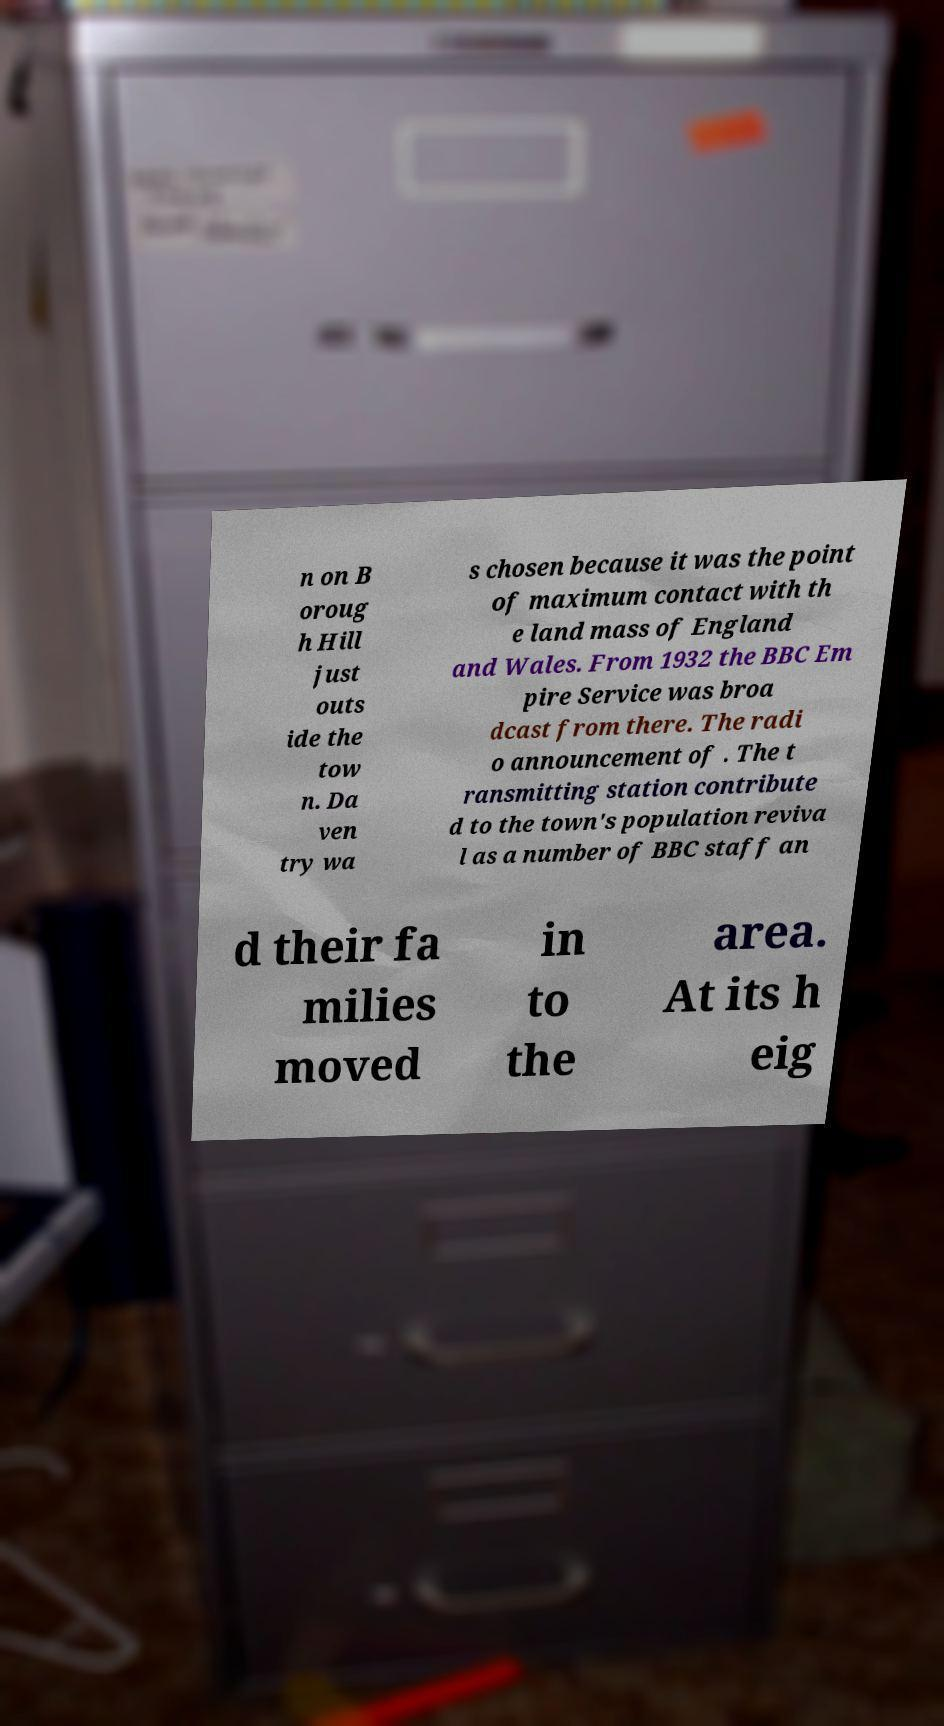Can you read and provide the text displayed in the image?This photo seems to have some interesting text. Can you extract and type it out for me? n on B oroug h Hill just outs ide the tow n. Da ven try wa s chosen because it was the point of maximum contact with th e land mass of England and Wales. From 1932 the BBC Em pire Service was broa dcast from there. The radi o announcement of . The t ransmitting station contribute d to the town's population reviva l as a number of BBC staff an d their fa milies moved in to the area. At its h eig 